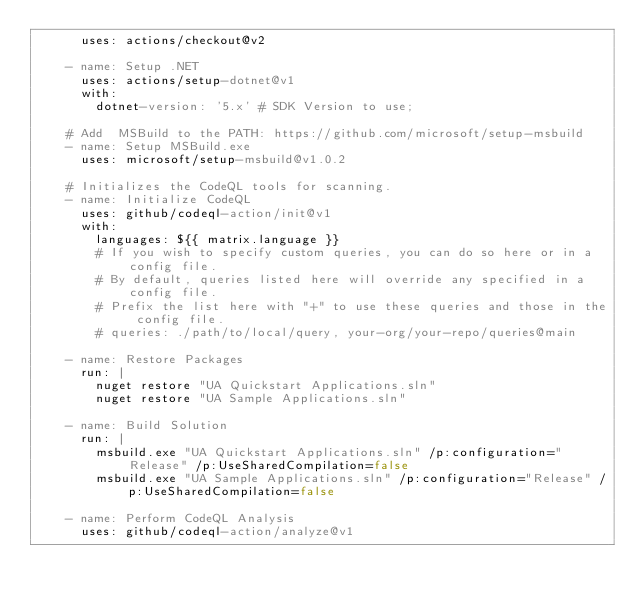Convert code to text. <code><loc_0><loc_0><loc_500><loc_500><_YAML_>      uses: actions/checkout@v2
      
    - name: Setup .NET
      uses: actions/setup-dotnet@v1
      with:
        dotnet-version: '5.x' # SDK Version to use;

    # Add  MSBuild to the PATH: https://github.com/microsoft/setup-msbuild
    - name: Setup MSBuild.exe
      uses: microsoft/setup-msbuild@v1.0.2

    # Initializes the CodeQL tools for scanning.
    - name: Initialize CodeQL
      uses: github/codeql-action/init@v1
      with:
        languages: ${{ matrix.language }}
        # If you wish to specify custom queries, you can do so here or in a config file.
        # By default, queries listed here will override any specified in a config file.
        # Prefix the list here with "+" to use these queries and those in the config file.
        # queries: ./path/to/local/query, your-org/your-repo/queries@main

    - name: Restore Packages
      run: |
        nuget restore "UA Quickstart Applications.sln"
        nuget restore "UA Sample Applications.sln"

    - name: Build Solution
      run: |
        msbuild.exe "UA Quickstart Applications.sln" /p:configuration="Release" /p:UseSharedCompilation=false
        msbuild.exe "UA Sample Applications.sln" /p:configuration="Release" /p:UseSharedCompilation=false

    - name: Perform CodeQL Analysis
      uses: github/codeql-action/analyze@v1
</code> 